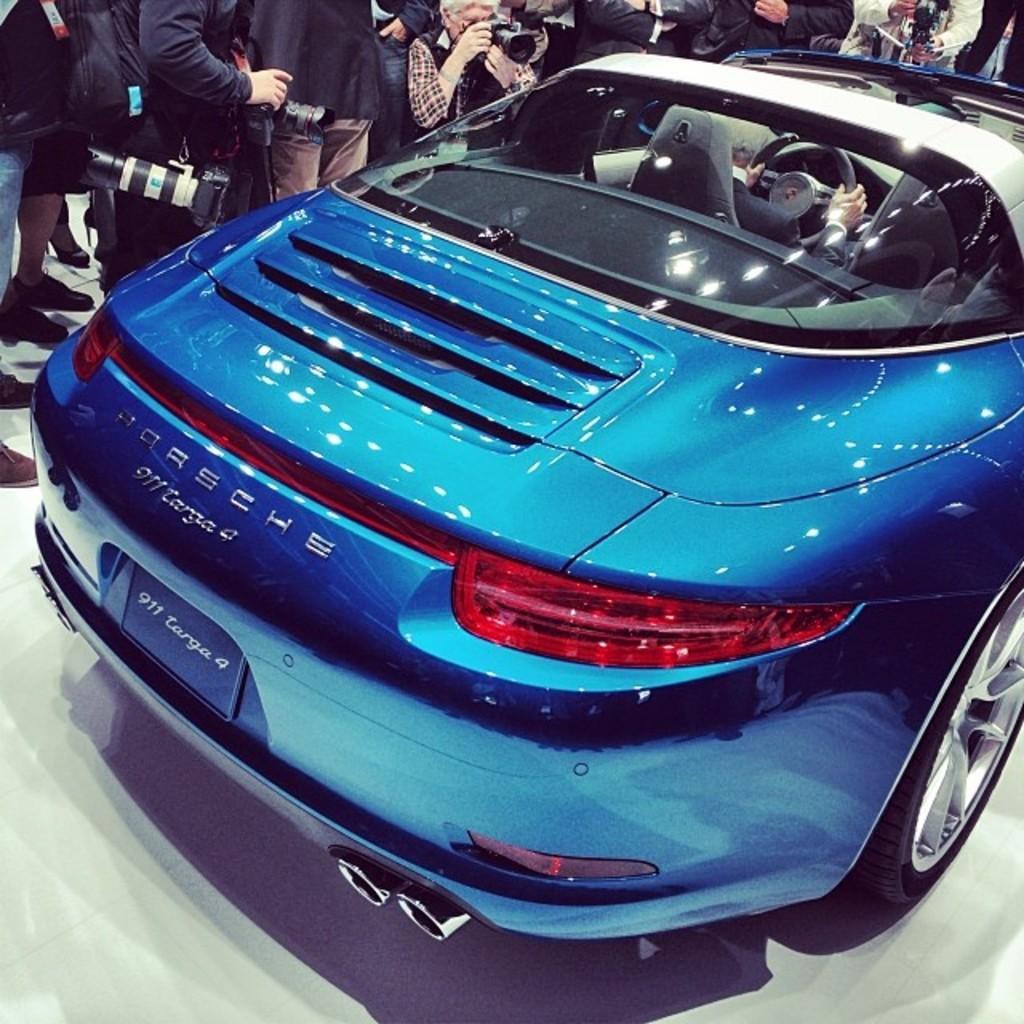In one or two sentences, can you explain what this image depicts? In this picture we can find group of people and a car, and we can see a person is seated in the car, and we can find few cameras. 